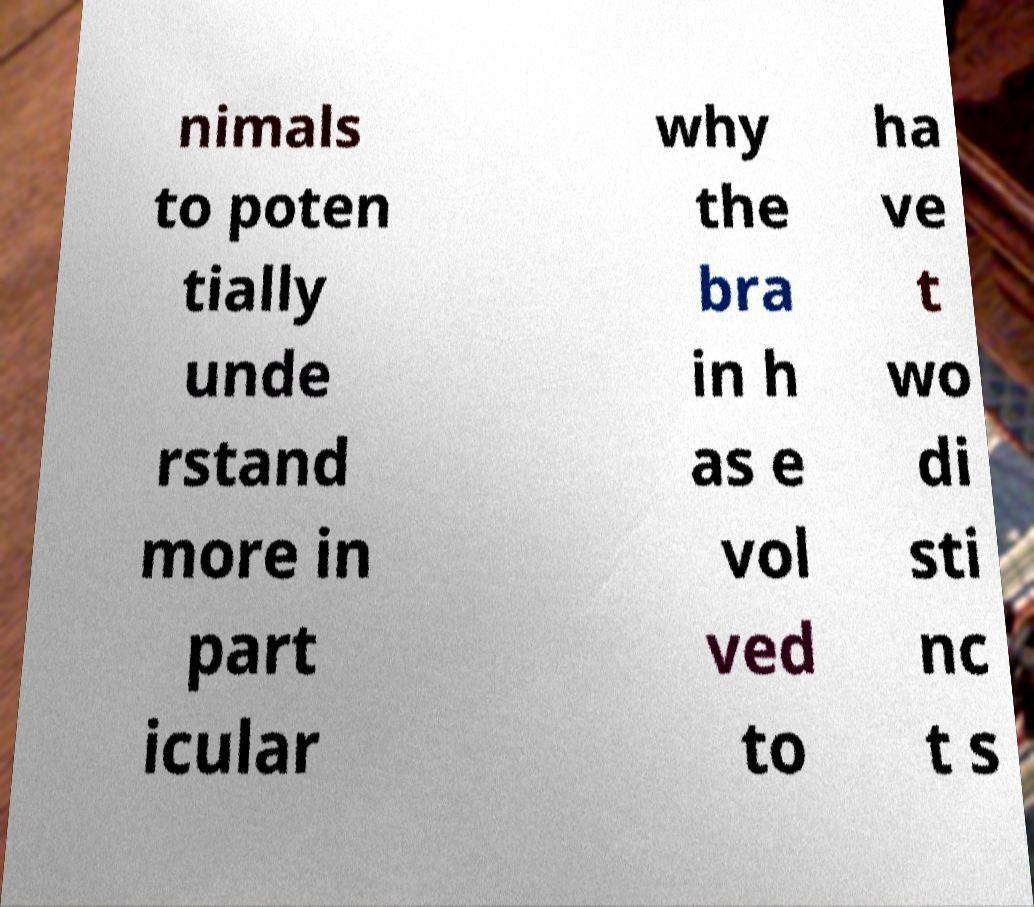Could you assist in decoding the text presented in this image and type it out clearly? nimals to poten tially unde rstand more in part icular why the bra in h as e vol ved to ha ve t wo di sti nc t s 